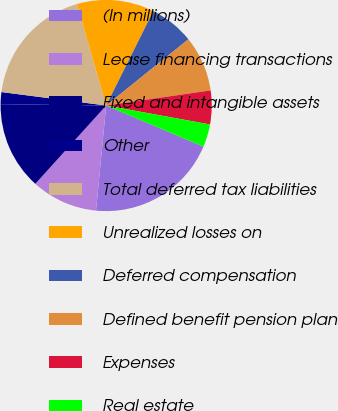Convert chart. <chart><loc_0><loc_0><loc_500><loc_500><pie_chart><fcel>(In millions)<fcel>Lease financing transactions<fcel>Fixed and intangible assets<fcel>Other<fcel>Total deferred tax liabilities<fcel>Unrealized losses on<fcel>Deferred compensation<fcel>Defined benefit pension plan<fcel>Expenses<fcel>Real estate<nl><fcel>20.17%<fcel>10.17%<fcel>13.5%<fcel>1.83%<fcel>18.51%<fcel>11.83%<fcel>6.83%<fcel>8.5%<fcel>5.16%<fcel>3.49%<nl></chart> 